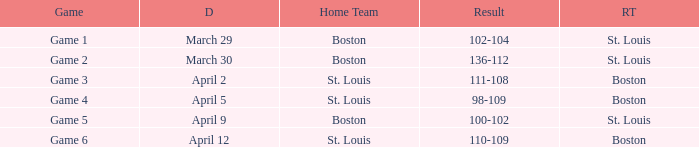What is the Game number on March 30? Game 2. 